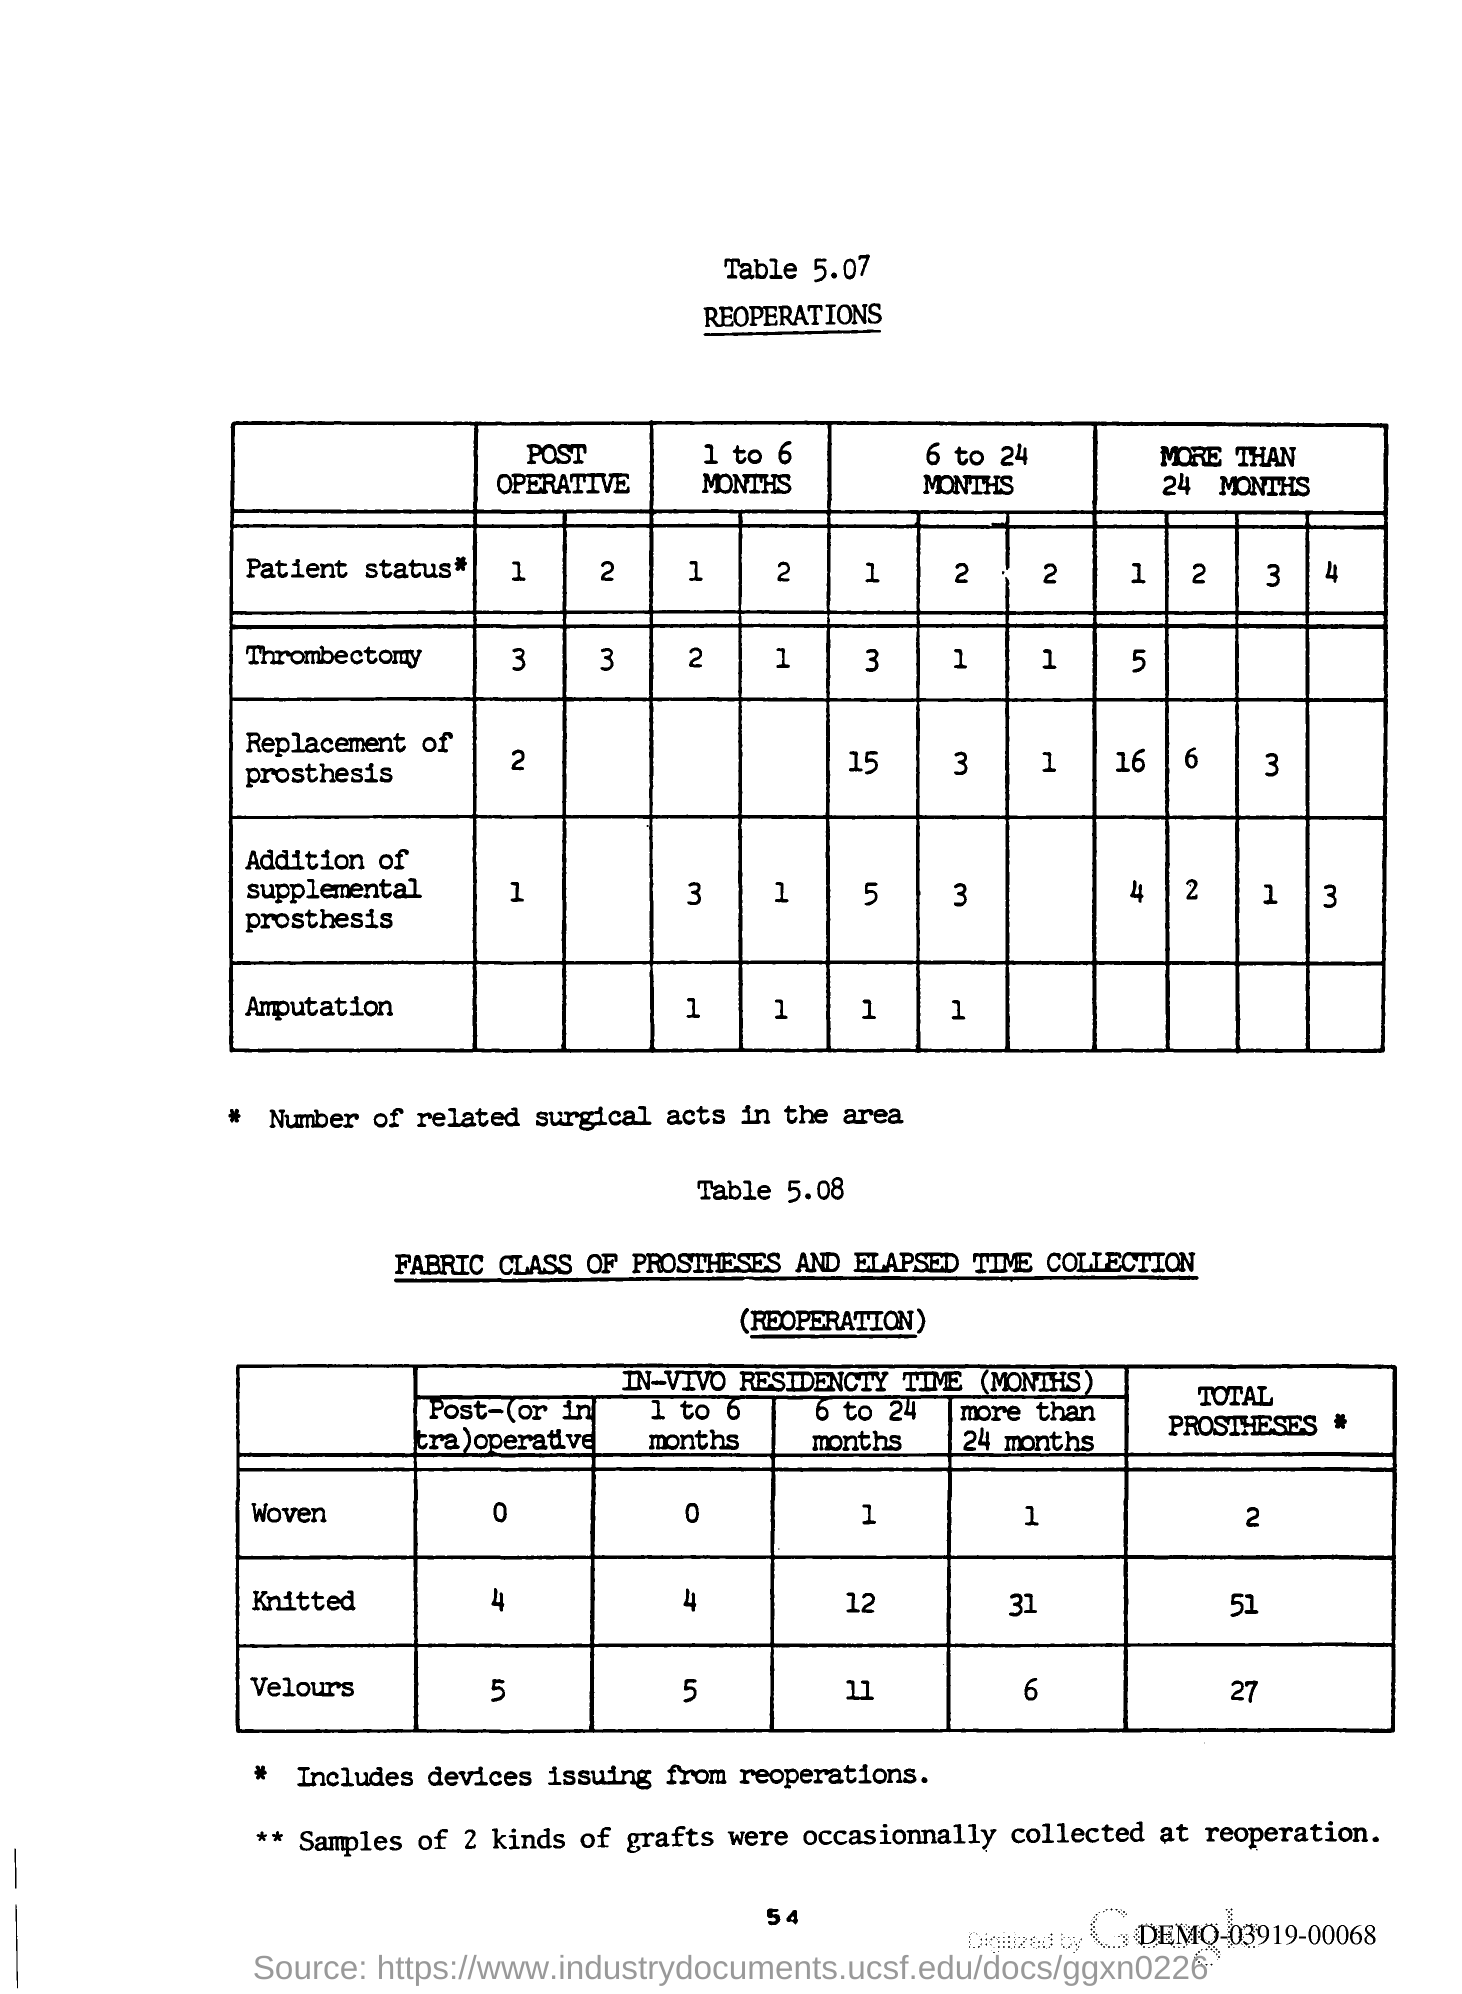Specify some key components in this picture. The page number is 54. 